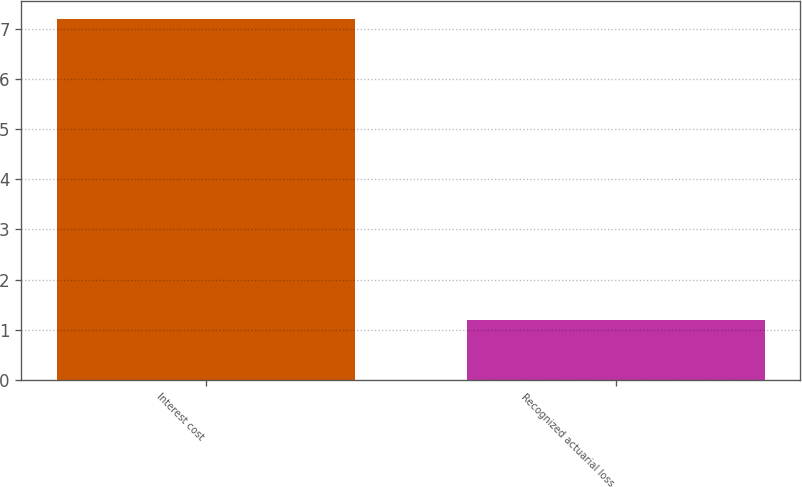<chart> <loc_0><loc_0><loc_500><loc_500><bar_chart><fcel>Interest cost<fcel>Recognized actuarial loss<nl><fcel>7.2<fcel>1.2<nl></chart> 